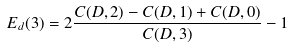Convert formula to latex. <formula><loc_0><loc_0><loc_500><loc_500>E _ { d } ( 3 ) = 2 \frac { C ( D , 2 ) - C ( D , 1 ) + C ( D , 0 ) } { C ( D , 3 ) } - 1</formula> 